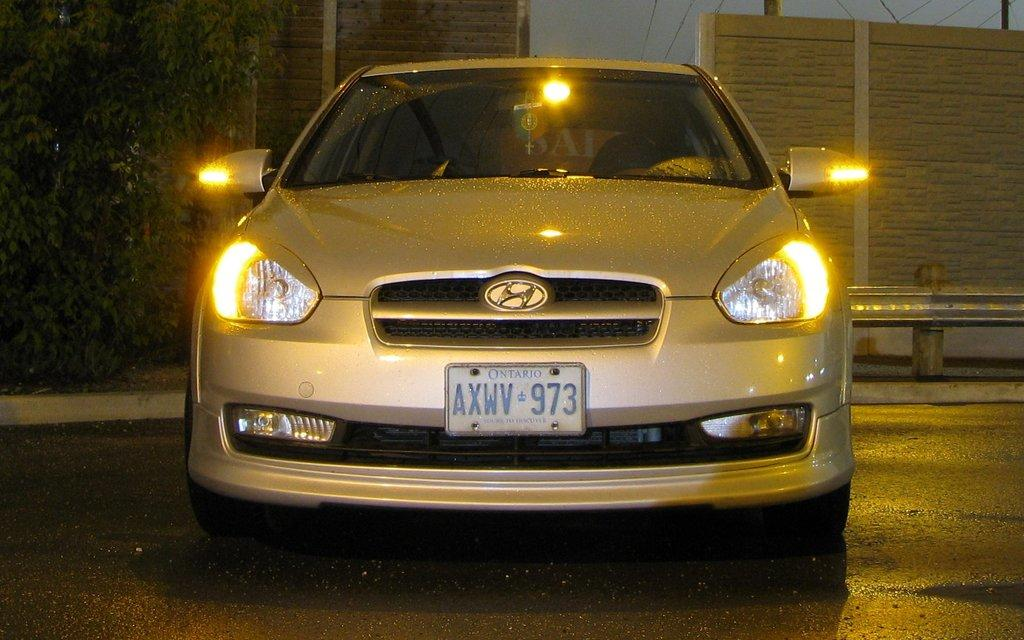What is the lighting condition in the image? The image was taken in the dark. What can be seen in the middle of the image? There is a car on the road in the middle of the image. What is visible in the background of the image? There is a wall and a railing in the background of the image. What type of vegetation is on the left side of the image? There are plants on the left side of the image. What type of knee injury can be seen in the image? There is no knee injury present in the image; it features a car on the road, a wall, a railing, and plants. What type of behavior is exhibited by the car in the image? The car in the image is stationary and not exhibiting any behavior, as it is a still image. 